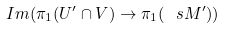Convert formula to latex. <formula><loc_0><loc_0><loc_500><loc_500>I m ( \pi _ { 1 } ( U ^ { \prime } \cap V ) \rightarrow \pi _ { 1 } ( \ s M ^ { \prime } ) )</formula> 